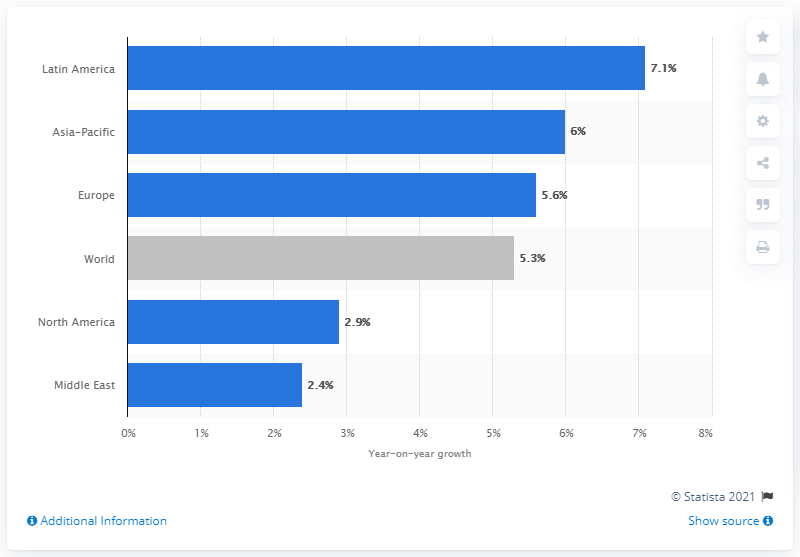Indicate a few pertinent items in this graphic. The passenger traffic in the Latin America region increased by 7.1% from 2017 to 2018. 